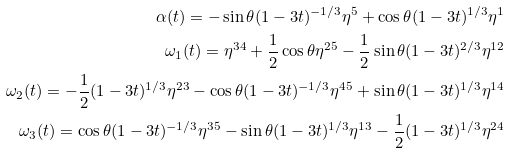Convert formula to latex. <formula><loc_0><loc_0><loc_500><loc_500>\alpha ( t ) = - \sin \theta ( 1 - 3 t ) ^ { - 1 / 3 } \eta ^ { 5 } + \cos \theta ( 1 - 3 t ) ^ { 1 / 3 } \eta ^ { 1 } \\ \omega _ { 1 } ( t ) = \eta ^ { 3 4 } + \frac { 1 } { 2 } \cos \theta \eta ^ { 2 5 } - \frac { 1 } { 2 } \sin \theta ( 1 - 3 t ) ^ { 2 / 3 } \eta ^ { 1 2 } \\ \omega _ { 2 } ( t ) = - \frac { 1 } { 2 } ( 1 - 3 t ) ^ { 1 / 3 } \eta ^ { 2 3 } - \cos \theta ( 1 - 3 t ) ^ { - 1 / 3 } \eta ^ { 4 5 } + \sin \theta ( 1 - 3 t ) ^ { 1 / 3 } \eta ^ { 1 4 } \\ \omega _ { 3 } ( t ) = \cos \theta ( 1 - 3 t ) ^ { - 1 / 3 } \eta ^ { 3 5 } - \sin \theta ( 1 - 3 t ) ^ { 1 / 3 } \eta ^ { 1 3 } - \frac { 1 } { 2 } ( 1 - 3 t ) ^ { 1 / 3 } \eta ^ { 2 4 }</formula> 